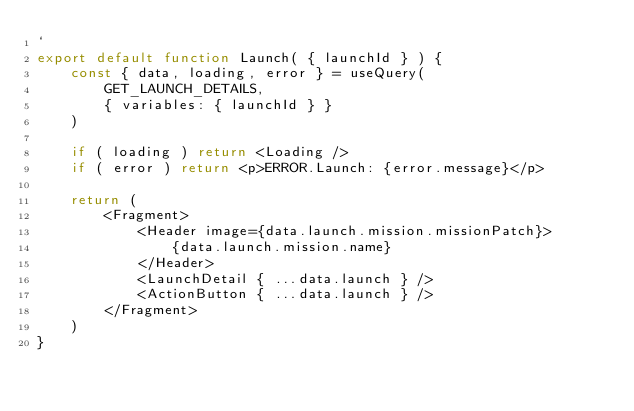Convert code to text. <code><loc_0><loc_0><loc_500><loc_500><_JavaScript_>`
export default function Launch( { launchId } ) {
    const { data, loading, error } = useQuery(
        GET_LAUNCH_DETAILS,
        { variables: { launchId } }
    )

    if ( loading ) return <Loading />
    if ( error ) return <p>ERROR.Launch: {error.message}</p>

    return (
        <Fragment>
            <Header image={data.launch.mission.missionPatch}>
                {data.launch.mission.name}
            </Header>
            <LaunchDetail { ...data.launch } />
            <ActionButton { ...data.launch } />
        </Fragment>
    )
}
</code> 